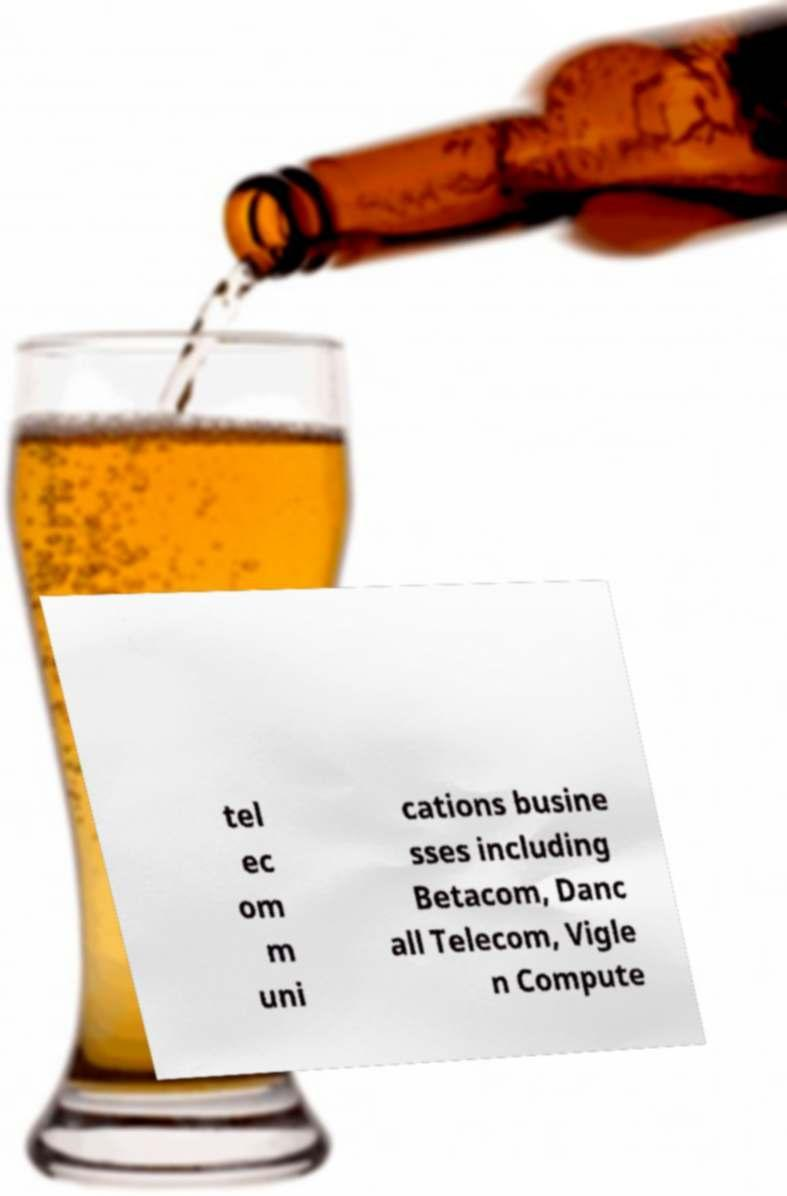Can you accurately transcribe the text from the provided image for me? tel ec om m uni cations busine sses including Betacom, Danc all Telecom, Vigle n Compute 